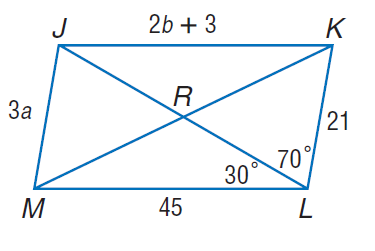Answer the mathemtical geometry problem and directly provide the correct option letter.
Question: Use parallelogram J K L M to find m \angle J K L if J K = 2 b + 3 and J M = 3 a.
Choices: A: 30 B: 70 C: 80 D: 100 C 